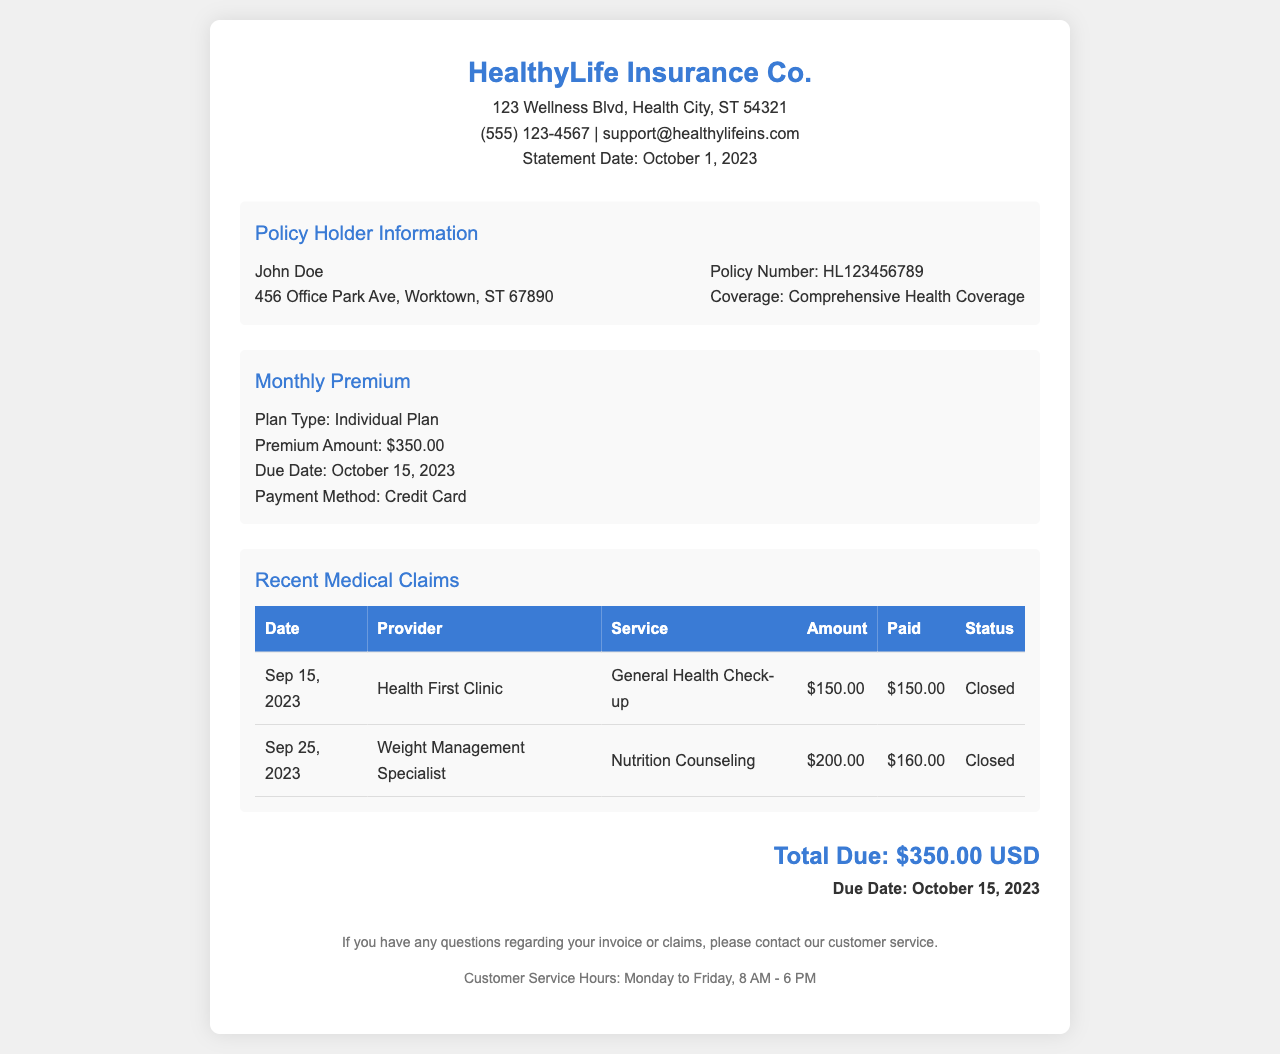What is the name of the insurance company? The invoice states the name of the company at the top, which is HealthyLife Insurance Co.
Answer: HealthyLife Insurance Co What is the policy number? The policy number is located in the policy info section, clearly identified as Policy Number.
Answer: HL123456789 What is the monthly premium amount? The monthly premium amount is specified under the Monthly Premium section.
Answer: $350.00 When is the payment due date? The due date for payment is found in the Monthly Premium section.
Answer: October 15, 2023 How much was paid for the Nutrition Counseling service? The amount paid is listed under the Recent Medical Claims section for the Nutrition Counseling service.
Answer: $160.00 What is the total amount due? The total due is provided at the bottom of the invoice, summarizing what is owed.
Answer: $350.00 USD What is the status of the General Health Check-up claim? The status of the claims is indicated in the Recent Medical Claims table.
Answer: Closed Which clinic provided the service on September 15, 2023? The provider for the service on that date is mentioned in the Recent Medical Claims section.
Answer: Health First Clinic What type of plan is held by the policyholder? The invoice specifies the type of plan in the Monthly Premium section.
Answer: Individual Plan 